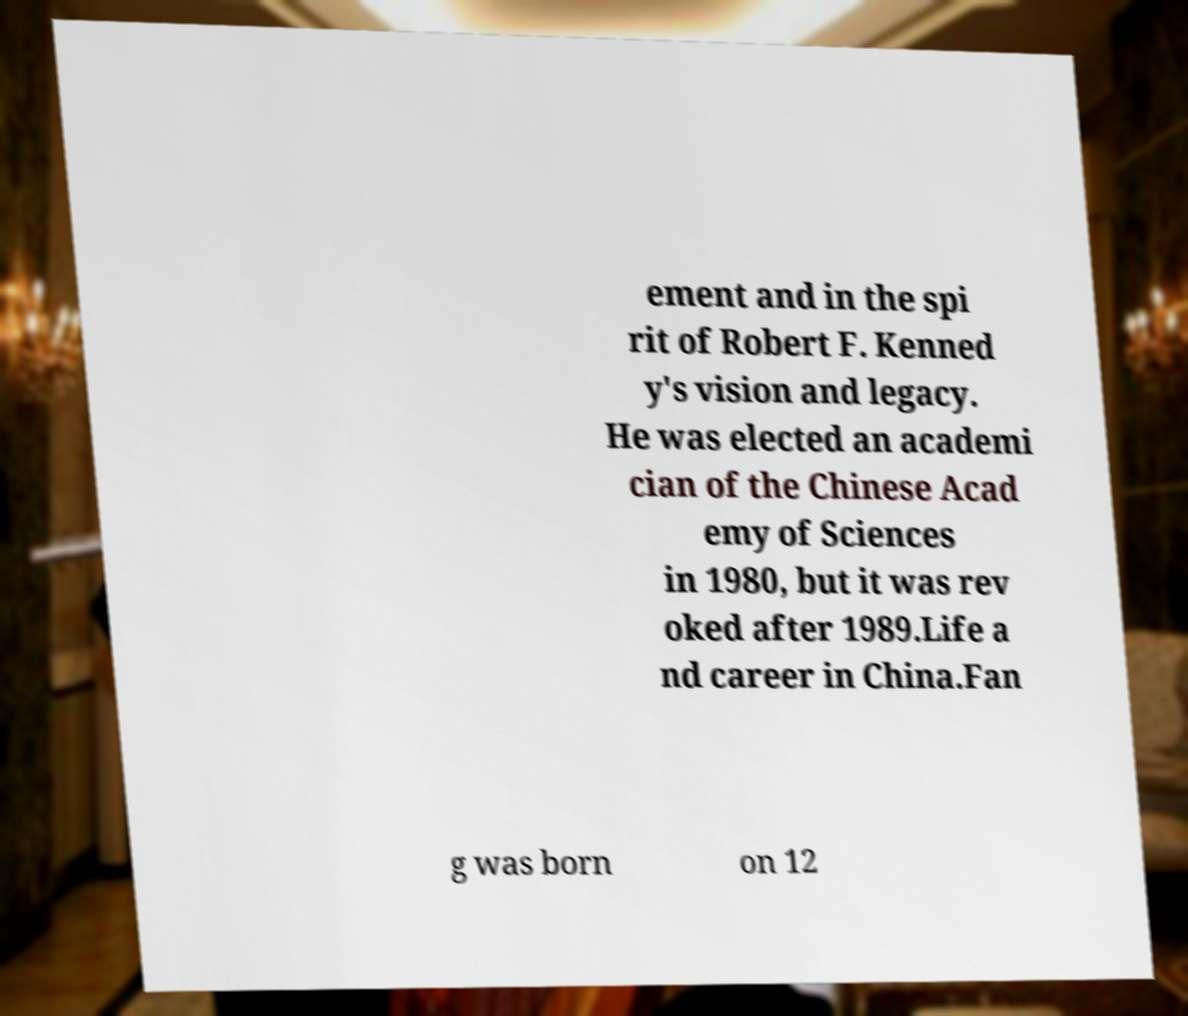There's text embedded in this image that I need extracted. Can you transcribe it verbatim? ement and in the spi rit of Robert F. Kenned y's vision and legacy. He was elected an academi cian of the Chinese Acad emy of Sciences in 1980, but it was rev oked after 1989.Life a nd career in China.Fan g was born on 12 